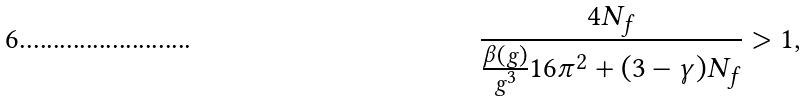Convert formula to latex. <formula><loc_0><loc_0><loc_500><loc_500>\frac { 4 N _ { f } } { \frac { \beta ( g ) } { g ^ { 3 } } 1 6 \pi ^ { 2 } + ( 3 - \gamma ) N _ { f } } > 1 ,</formula> 